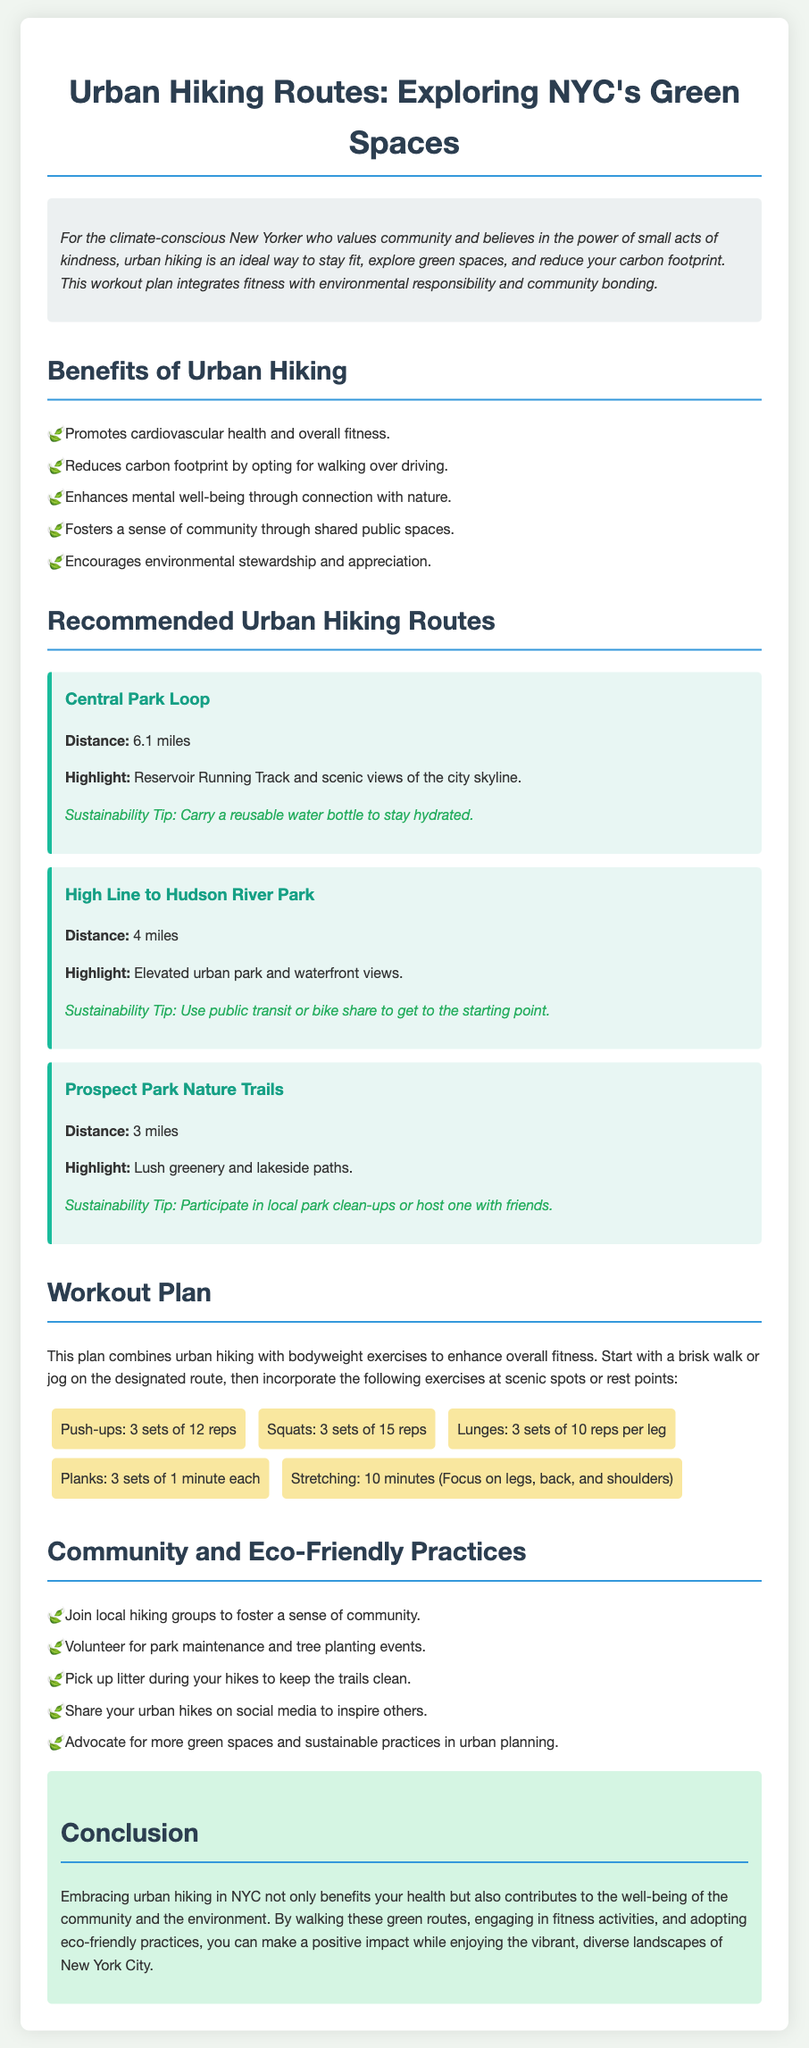what is the distance of the Central Park Loop? The distance of the Central Park Loop is clearly stated in the document as 6.1 miles.
Answer: 6.1 miles what are the highlights of the High Line to Hudson River Park route? The highlights for this route are mentioned as the elevated urban park and waterfront views.
Answer: Elevated urban park and waterfront views how many sets of planks are recommended in the workout plan? The workout plan specifies 3 sets of 1 minute each for planks.
Answer: 3 sets which eco-friendly practice involves community involvement? The document outlines volunteering for park maintenance and tree planting events as a community-involved eco-friendly practice.
Answer: Volunteer for park maintenance and tree planting events what is one sustainability tip provided for the Prospect Park Nature Trails? A sustainability tip for this route encourages participating in local park clean-ups or hosting one with friends.
Answer: Participate in local park clean-ups or host one with friends how does urban hiking benefit mental well-being? The document states that urban hiking enhances mental well-being through connection with nature, highlighting its impact on mental health.
Answer: Connection with nature what is the primary goal of the workout plan? The main goal of the workout plan is to combine urban hiking with bodyweight exercises to enhance overall fitness while enjoying nature.
Answer: Enhance overall fitness what is the total distance covered by the recommended urban hiking routes? The sum of the distances of all three hiking routes gives the total distance as 6.1 miles + 4 miles + 3 miles.
Answer: 13.1 miles 